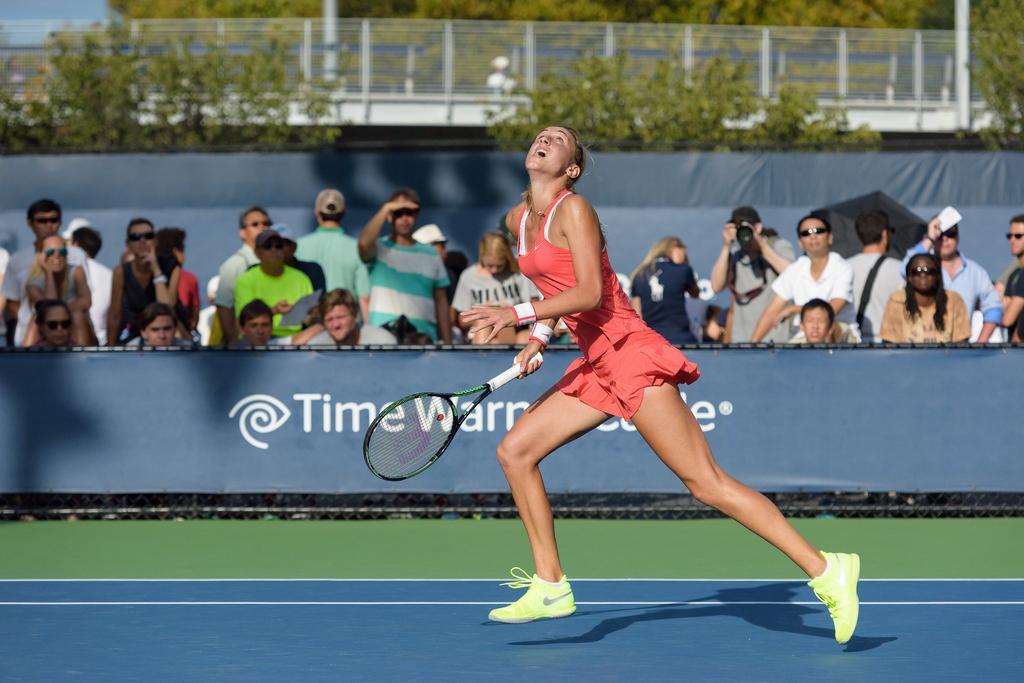Describe this image in one or two sentences. On the tennis court there is a lady with pink dress is running. She is holding a racket in her hand. She is looking up. In the background there is poster. Behind the poster there are many people standing and watching her. On the top there is a bridge and some trees. 